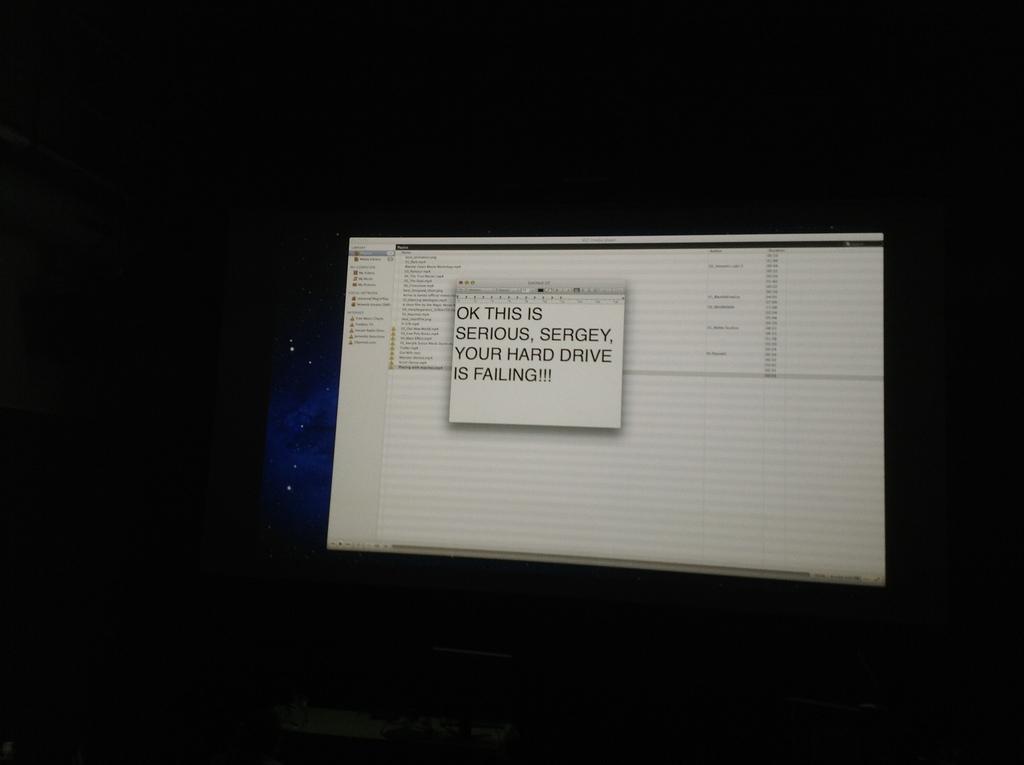What is the person's name that is referenced in the text?
Give a very brief answer. Sergey. What is failing?
Your answer should be compact. Hard drive. 